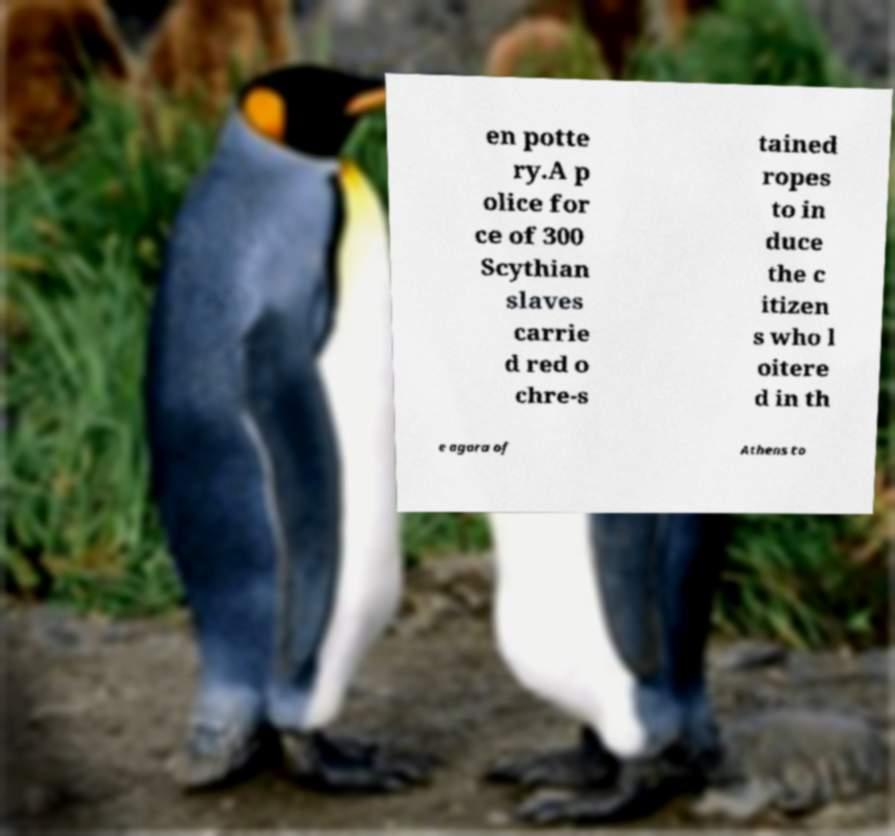Can you accurately transcribe the text from the provided image for me? en potte ry.A p olice for ce of 300 Scythian slaves carrie d red o chre-s tained ropes to in duce the c itizen s who l oitere d in th e agora of Athens to 